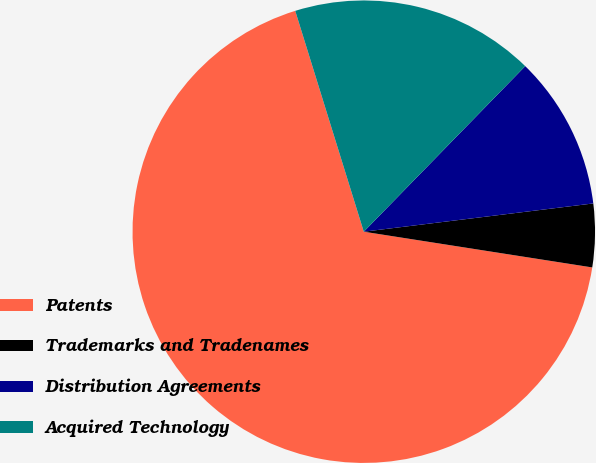Convert chart. <chart><loc_0><loc_0><loc_500><loc_500><pie_chart><fcel>Patents<fcel>Trademarks and Tradenames<fcel>Distribution Agreements<fcel>Acquired Technology<nl><fcel>67.74%<fcel>4.42%<fcel>10.75%<fcel>17.09%<nl></chart> 